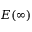<formula> <loc_0><loc_0><loc_500><loc_500>E ( \infty )</formula> 